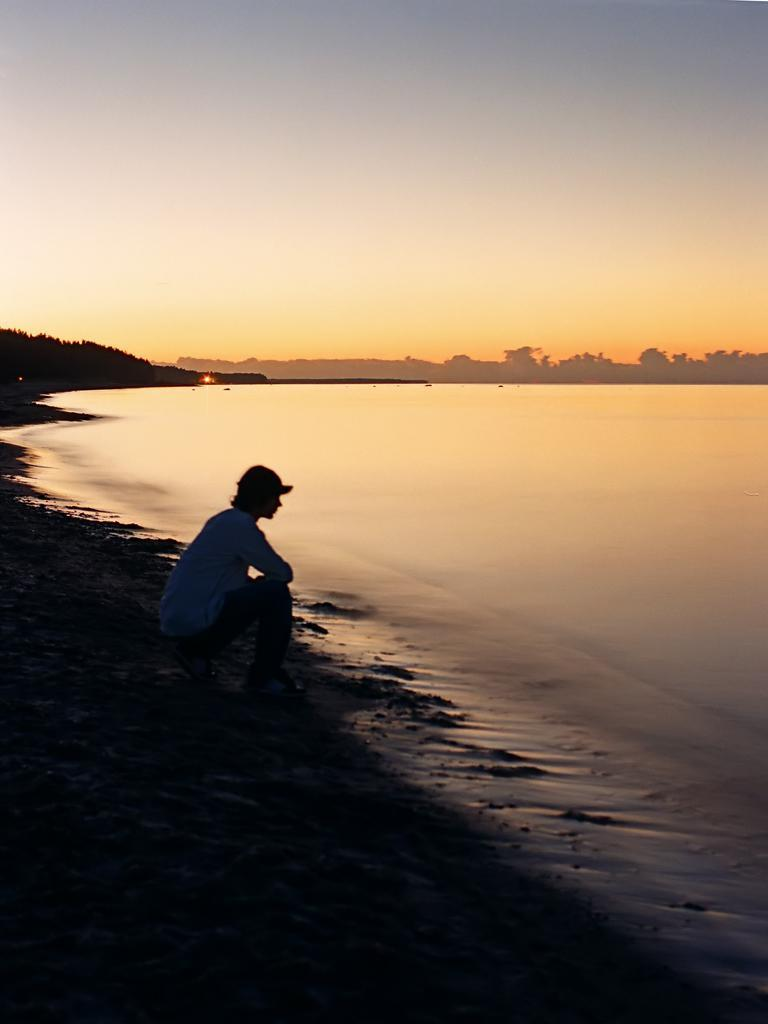What position is the person in the image? The person is in the squat position sitting on the sand. What is the lighting condition in the image? The person is in the dark. What can be seen in the background of the image? There is water, trees, and the sky visible in the background. Where is the shelf located in the image? There is no shelf present in the image. What type of leaf can be seen falling from the trees in the image? There are no leaves visible in the image, as it is dark and the trees are in the background. 